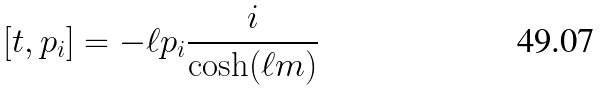Convert formula to latex. <formula><loc_0><loc_0><loc_500><loc_500>\left [ t , p _ { i } \right ] = - \ell p _ { i } \frac { i } { \cosh ( \ell m ) }</formula> 